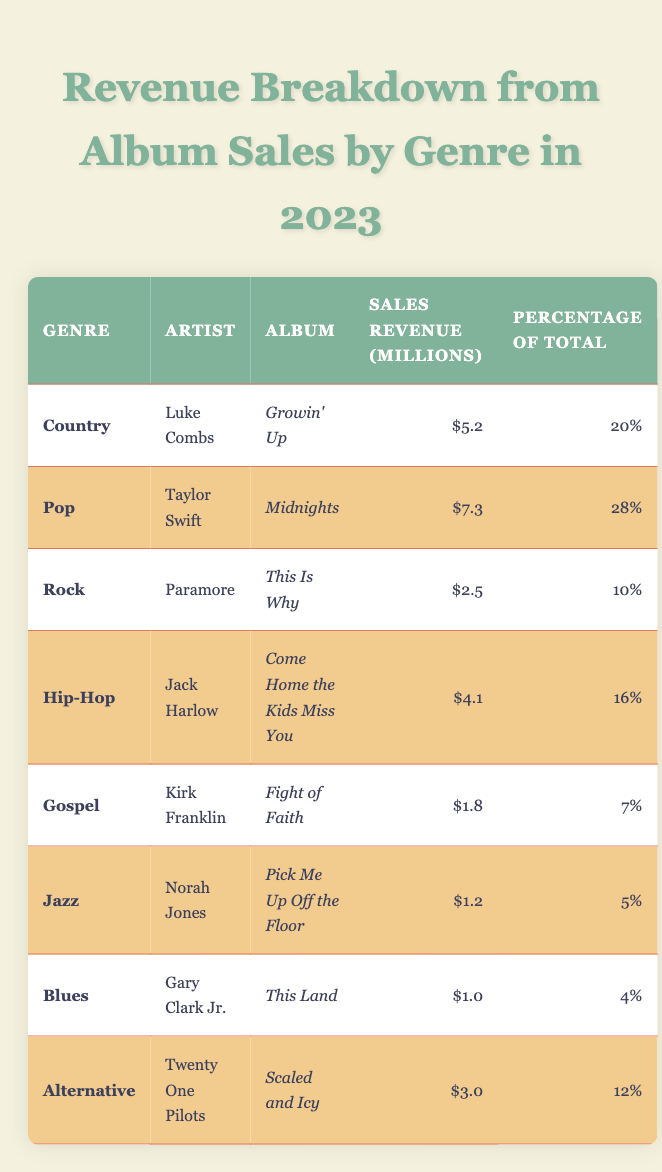What is the total revenue from album sales in the Jazz genre? The revenue for Jazz is listed as $1.2 million in the table.
Answer: $1.2 million Who had the highest sales revenue in 2023? The highest sales revenue is from Taylor Swift with $7.3 million from the album *Midnights*.
Answer: Taylor Swift What percentage of total sales revenue did the Blues genre represent? The Blues genre contributed 4% to the total sales revenue according to the table.
Answer: 4% Which genre had the lowest sales revenue? The lowest sales revenue is in the Gospel genre, which is $1.8 million, while Jazz ($1.2 million) and Blues ($1.0 million) are lower in revenue.
Answer: Jazz How much sales revenue does the Country genre represent in percentage? The Country genre represents 20% of the total sales revenue, as indicated in the table.
Answer: 20% If you sum the sales revenue of Rock and Blues genres, what do you get? Rock's revenue is $2.5 million and Blues is $1.0 million. Summing these gives $2.5 million + $1.0 million = $3.5 million.
Answer: $3.5 million Is it true that the album *Come Home the Kids Miss You* contributed less revenue than *Growin' Up*? The revenue for *Come Home the Kids Miss You* is $4.1 million, which is less than *Growin' Up*, which is $5.2 million. Therefore, the statement is true.
Answer: True What is the total revenue from Hip-Hop and Alternative genres? The Hip-Hop revenue is $4.1 million and Alternative is $3.0 million. Adding these gives $4.1 million + $3.0 million = $7.1 million.
Answer: $7.1 million Which artist sold more albums, Luke Combs or Jack Harlow? Luke Combs has revenue of $5.2 million from *Growin' Up*, while Jack Harlow has $4.1 million from *Come Home the Kids Miss You*. Thus, Luke Combs sold more.
Answer: Luke Combs What is the combined percentage of total revenue for Country and Pop genres? The percentages are 20% for Country and 28% for Pop. Combining these gives 20% + 28% = 48%.
Answer: 48% Which genre accounted for more than 15% of the total revenue? Pop is the only genre that accounts for more than 15% with 28%.
Answer: Pop 